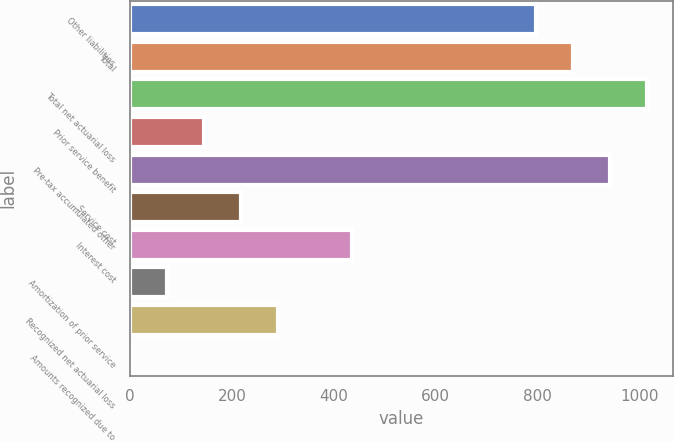Convert chart. <chart><loc_0><loc_0><loc_500><loc_500><bar_chart><fcel>Other liabilities<fcel>Total<fcel>Total net actuarial loss<fcel>Prior service benefit<fcel>Pre-tax accumulated other<fcel>Service cost<fcel>Interest cost<fcel>Amortization of prior service<fcel>Recognized net actuarial loss<fcel>Amounts recognized due to<nl><fcel>797.46<fcel>869.92<fcel>1014.84<fcel>145.32<fcel>942.38<fcel>217.78<fcel>435.16<fcel>72.86<fcel>290.24<fcel>0.4<nl></chart> 